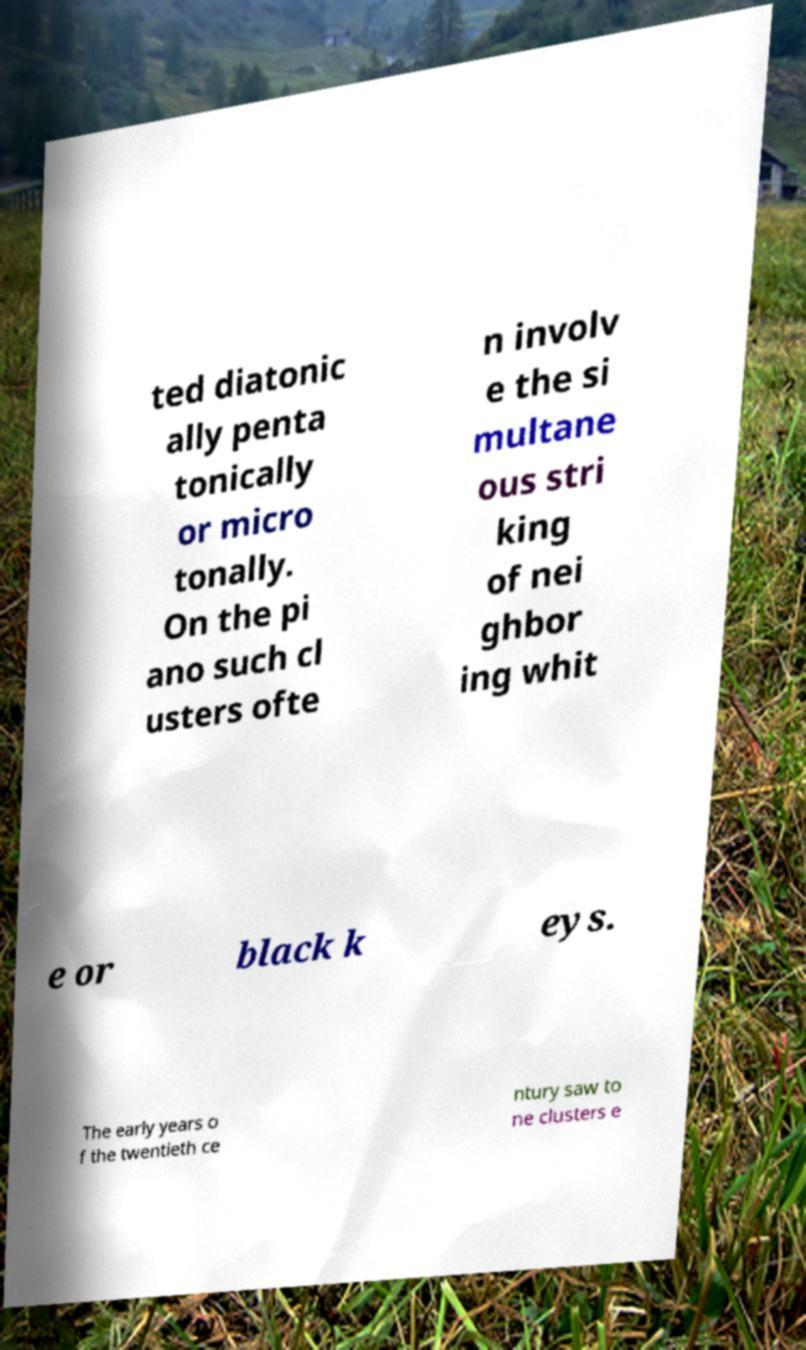Please read and relay the text visible in this image. What does it say? ted diatonic ally penta tonically or micro tonally. On the pi ano such cl usters ofte n involv e the si multane ous stri king of nei ghbor ing whit e or black k eys. The early years o f the twentieth ce ntury saw to ne clusters e 